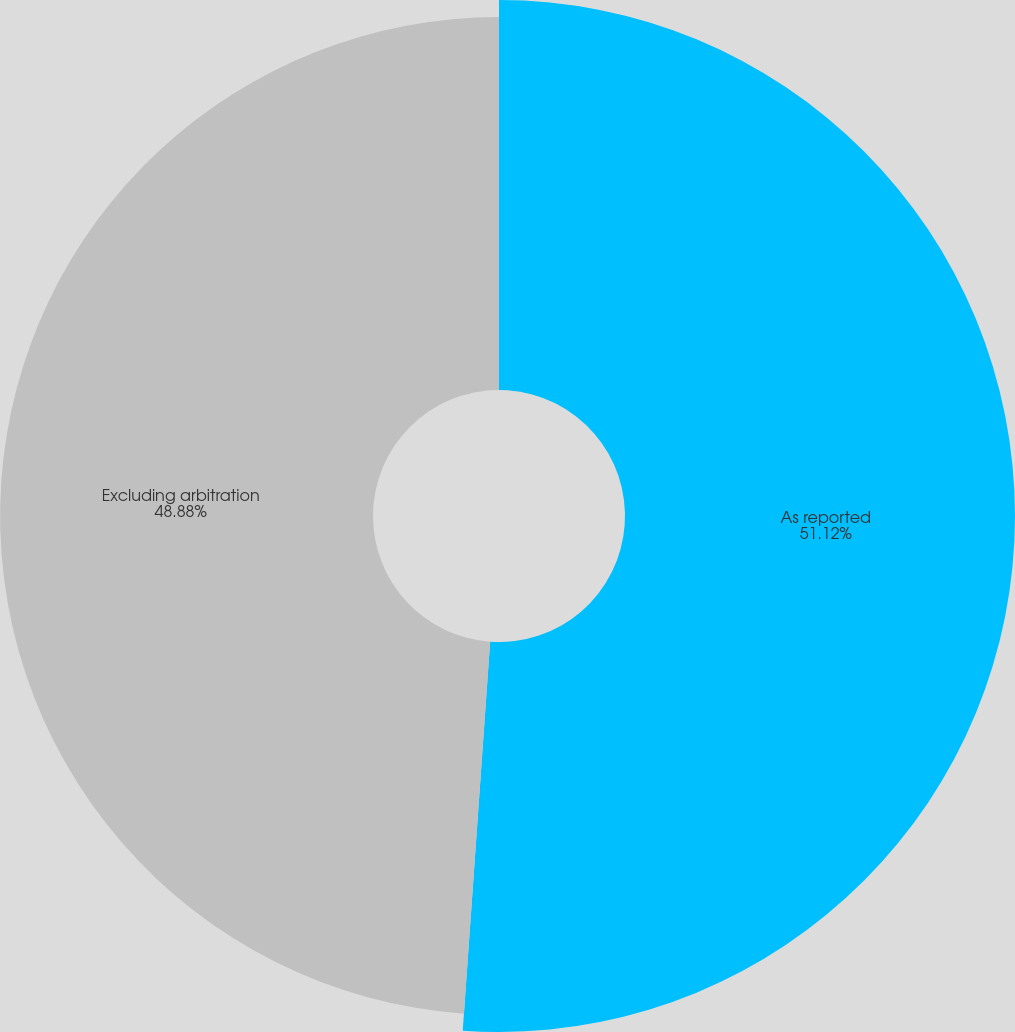Convert chart. <chart><loc_0><loc_0><loc_500><loc_500><pie_chart><fcel>As reported<fcel>Excluding arbitration<nl><fcel>51.12%<fcel>48.88%<nl></chart> 